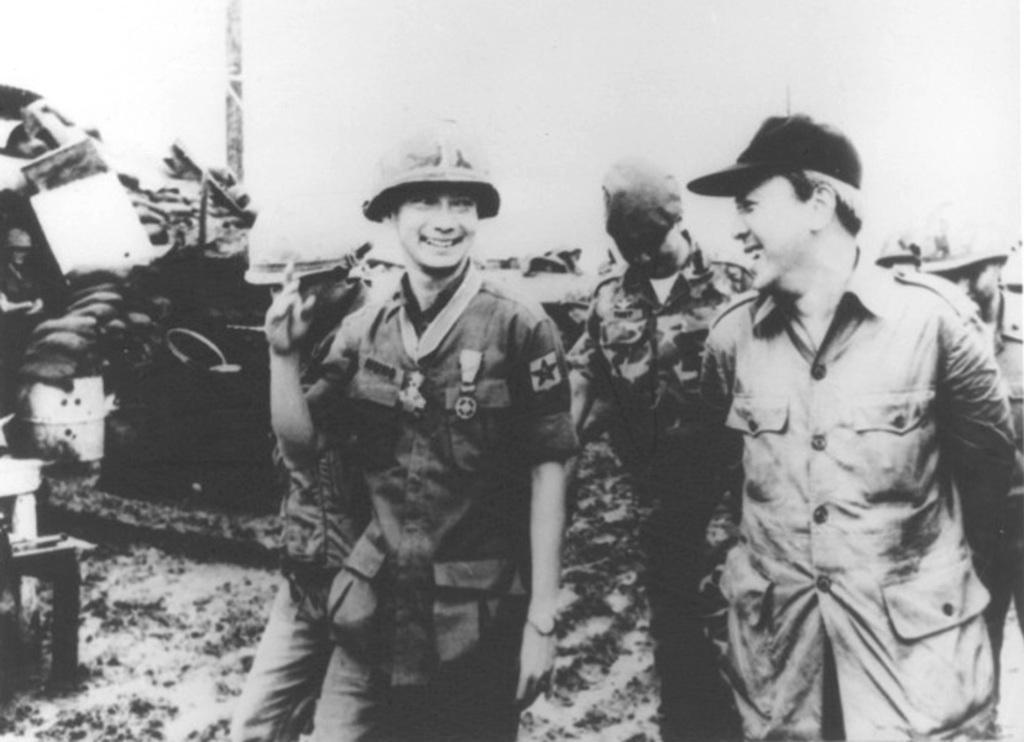Please provide a concise description of this image. It is an old black and white picture, there are few people laughing by seeing at each other and behind them there are some objects. 